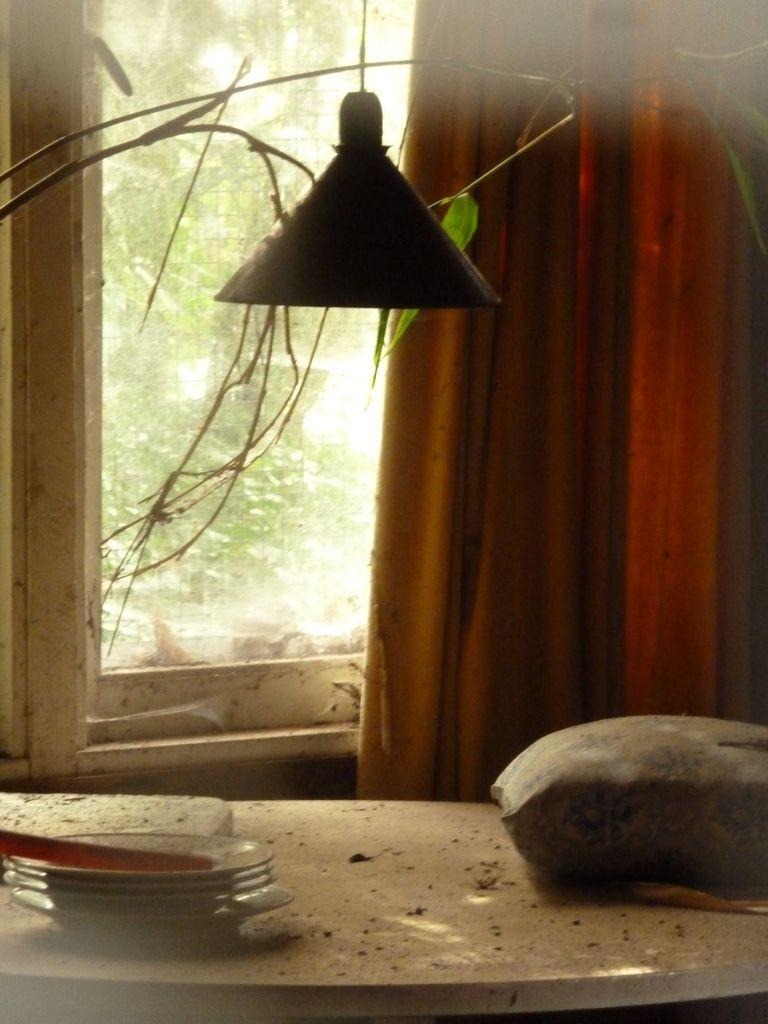What can be seen in the image that provides illumination? There is light in the image. What is located on a surface in the image? There are objects on a table in the image. What type of window treatment is present in the image? There is a curtain in the image. What is the purpose of the window in the image? There is a window in the image, and trees are visible through it. What type of locket is hanging from the tree in the image? There is no locket present in the image; the trees are visible through the window. What is being served for dinner in the image? The image does not depict a dinner or any food being served. 